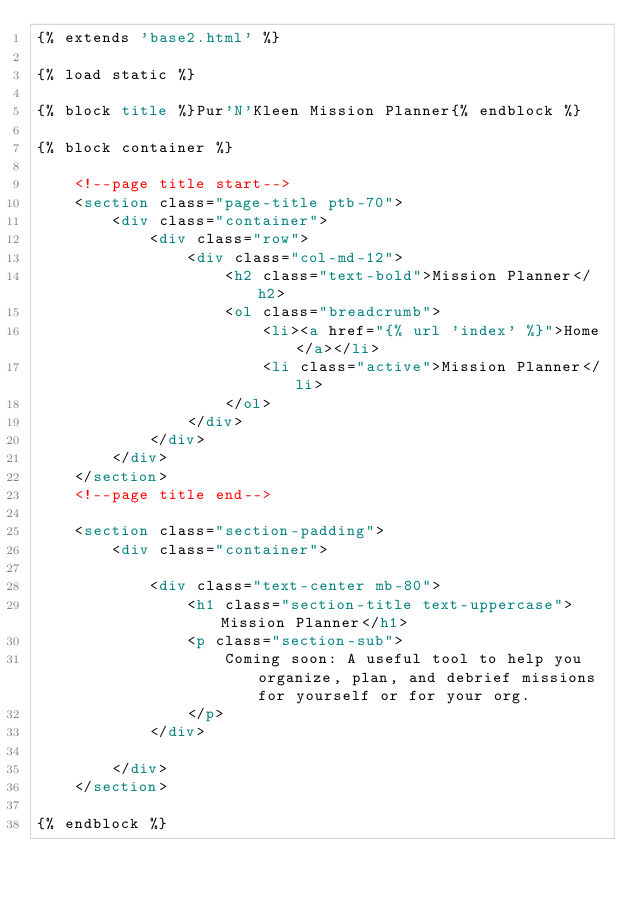Convert code to text. <code><loc_0><loc_0><loc_500><loc_500><_HTML_>{% extends 'base2.html' %}

{% load static %}

{% block title %}Pur'N'Kleen Mission Planner{% endblock %}

{% block container %}

    <!--page title start-->
    <section class="page-title ptb-70">
        <div class="container">
            <div class="row">
                <div class="col-md-12">
                    <h2 class="text-bold">Mission Planner</h2>
                    <ol class="breadcrumb">
                        <li><a href="{% url 'index' %}">Home</a></li>
                        <li class="active">Mission Planner</li>
                    </ol>
                </div>
            </div>
        </div>
    </section>
    <!--page title end-->

    <section class="section-padding">
        <div class="container">

            <div class="text-center mb-80">
                <h1 class="section-title text-uppercase">Mission Planner</h1>
                <p class="section-sub">
                    Coming soon: A useful tool to help you organize, plan, and debrief missions for yourself or for your org.
                </p>
            </div>

        </div>
    </section>

{% endblock %}</code> 